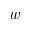Convert formula to latex. <formula><loc_0><loc_0><loc_500><loc_500>w</formula> 